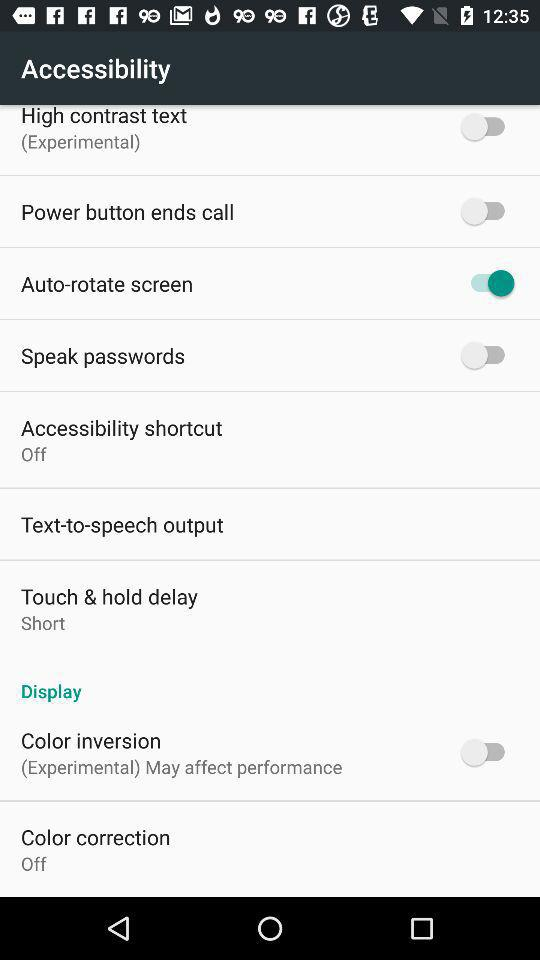What is the status of "Auto-rotate screen"? The status is "on". 